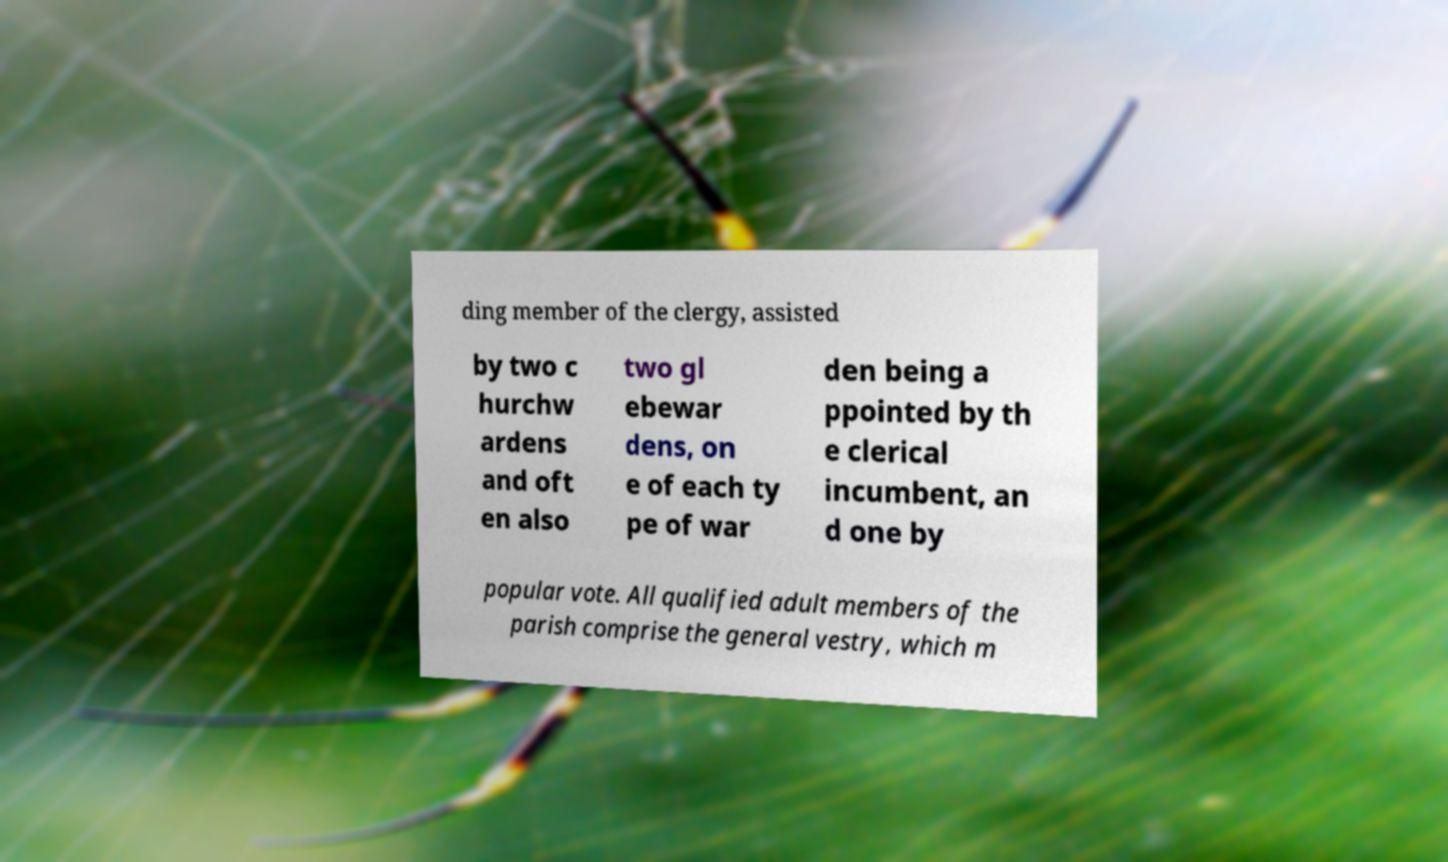For documentation purposes, I need the text within this image transcribed. Could you provide that? ding member of the clergy, assisted by two c hurchw ardens and oft en also two gl ebewar dens, on e of each ty pe of war den being a ppointed by th e clerical incumbent, an d one by popular vote. All qualified adult members of the parish comprise the general vestry, which m 